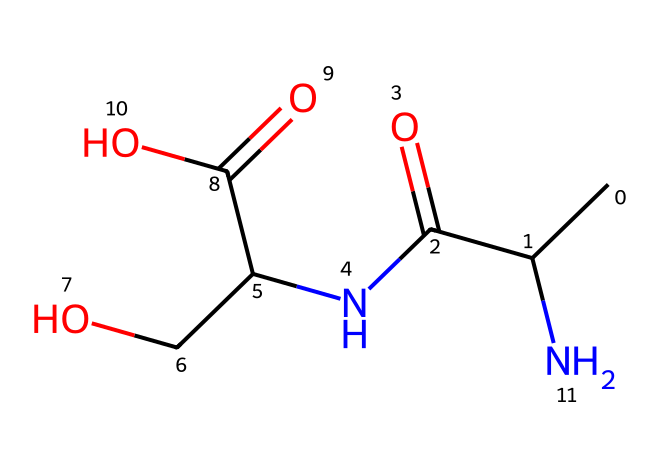What is the main functional group in this molecule? The main functional group present in the molecule is the amide, indicated by the -C(=O)N- structure. This is derived from the carbonyl group attached to a nitrogen atom.
Answer: amide How many carbon atoms are in the structure? By counting the carbon atoms present in the SMILES representation, there are a total of 6 carbon atoms, which are represented by 'C' in the SMILES.
Answer: 6 What type of chemical is this? This chemical structure corresponds to a peptide, which is indicated by the presence of amide bonds between amino acids.
Answer: peptide How many functional groups are present in this molecule? The molecule contains three functional groups: one amide, one carboxylic acid (-COOH), and one alcohol (-OH). Each of these groups contributes to the molecule's properties.
Answer: 3 What is the oxidation state of the carbonyl carbon in the amide? The carbonyl carbon in the amide has an oxidation state of +2, as it is double-bonded to oxygen (making it a carbonyl) and single-bonded to nitrogen (part of the amide).
Answer: +2 Which part of the molecule contributes to its solubility in water? The presence of the -COOH (carboxylic acid) and -OH (alcohol) groups enhances solubility due to their ability to form hydrogen bonds with water.
Answer: carboxylic acid and alcohol What type of reaction could this molecule undergo? This molecule could undergo hydrolysis, as the amide bond can break in the presence of water, leading to the formation of its constituent amino acids.
Answer: hydrolysis 